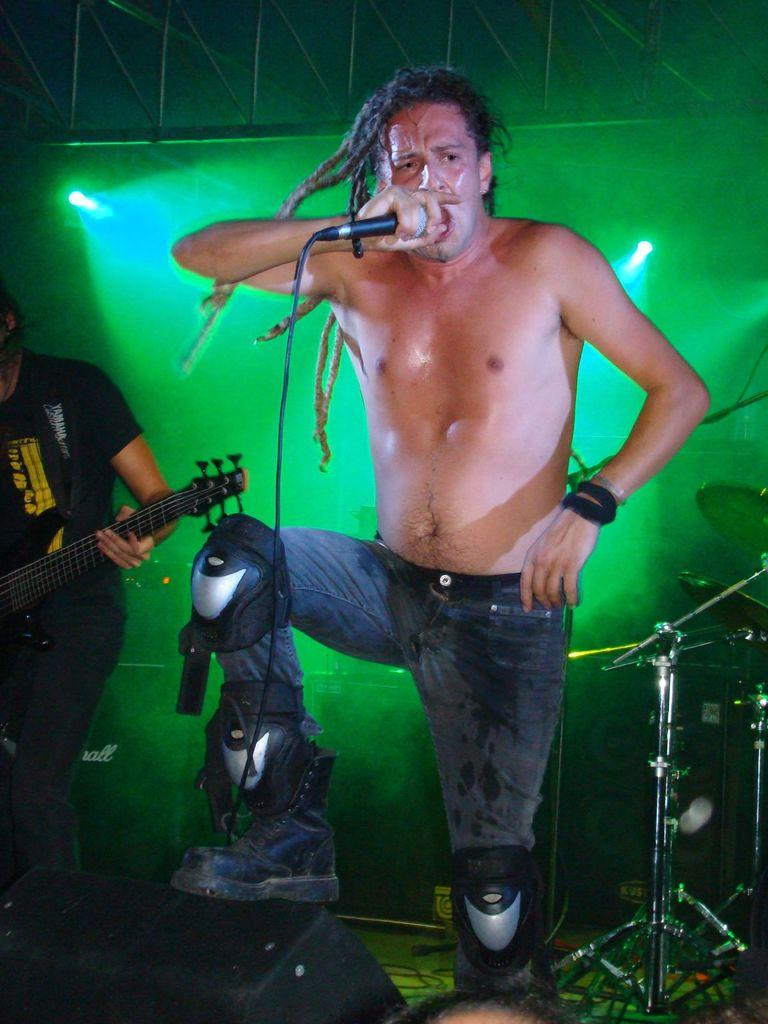What is the man in the image doing? The man is standing and singing in the image. What object is the man interacting with while singing? The man is in front of a microphone. Who else is present in the image? There is a person holding a guitar in the image. What can be seen in the background of the image? There are lights visible in the background of the image. What type of lunchroom is the man singing in during the image? There is no mention of a lunchroom in the image; it does not appear to be taking place in a lunchroom setting. 